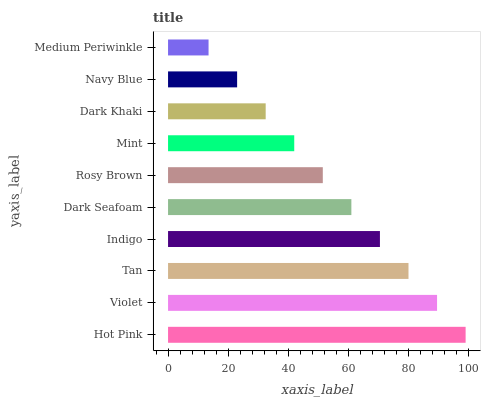Is Medium Periwinkle the minimum?
Answer yes or no. Yes. Is Hot Pink the maximum?
Answer yes or no. Yes. Is Violet the minimum?
Answer yes or no. No. Is Violet the maximum?
Answer yes or no. No. Is Hot Pink greater than Violet?
Answer yes or no. Yes. Is Violet less than Hot Pink?
Answer yes or no. Yes. Is Violet greater than Hot Pink?
Answer yes or no. No. Is Hot Pink less than Violet?
Answer yes or no. No. Is Dark Seafoam the high median?
Answer yes or no. Yes. Is Rosy Brown the low median?
Answer yes or no. Yes. Is Medium Periwinkle the high median?
Answer yes or no. No. Is Dark Khaki the low median?
Answer yes or no. No. 